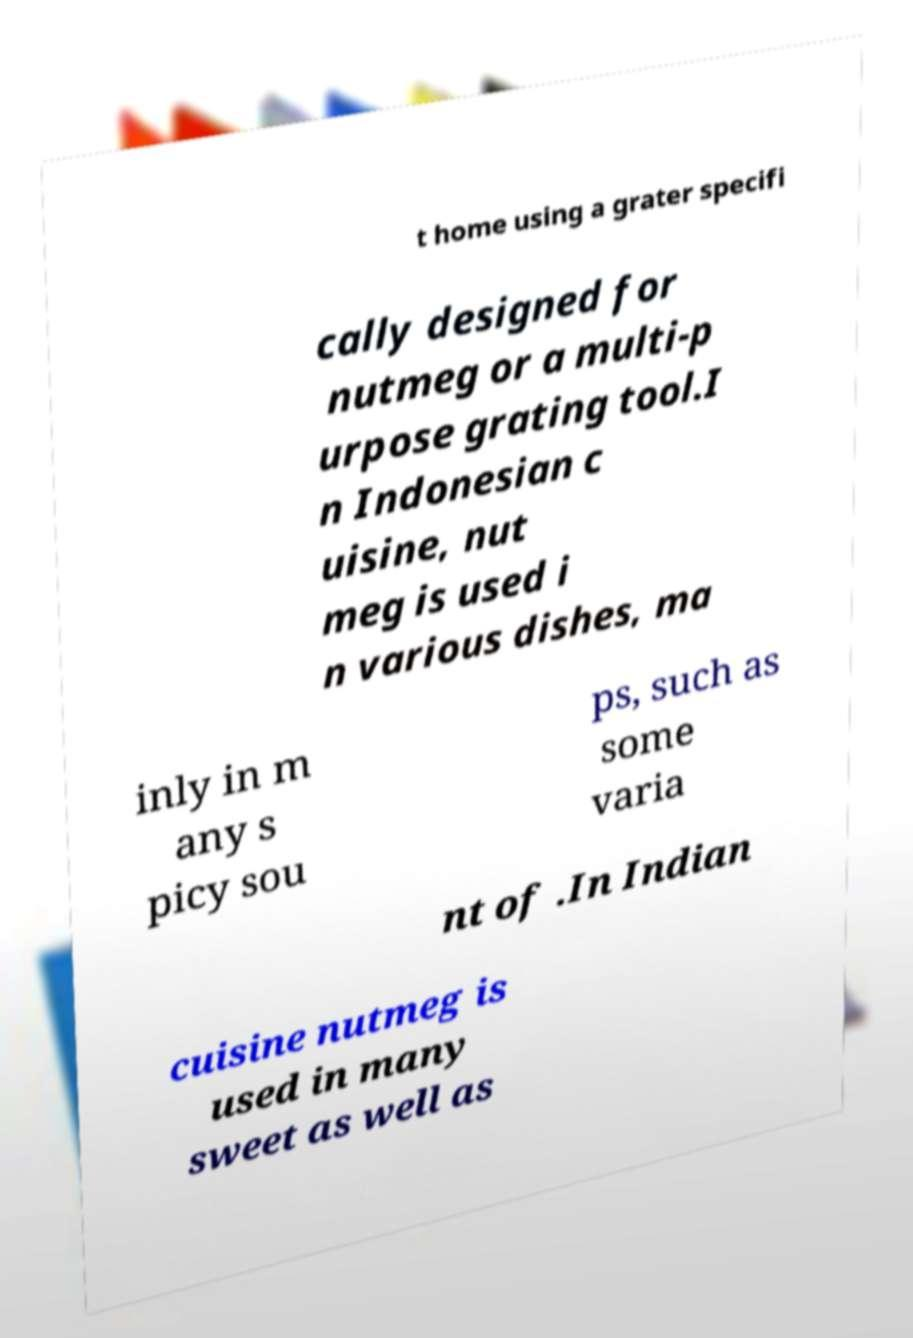Please identify and transcribe the text found in this image. t home using a grater specifi cally designed for nutmeg or a multi-p urpose grating tool.I n Indonesian c uisine, nut meg is used i n various dishes, ma inly in m any s picy sou ps, such as some varia nt of .In Indian cuisine nutmeg is used in many sweet as well as 